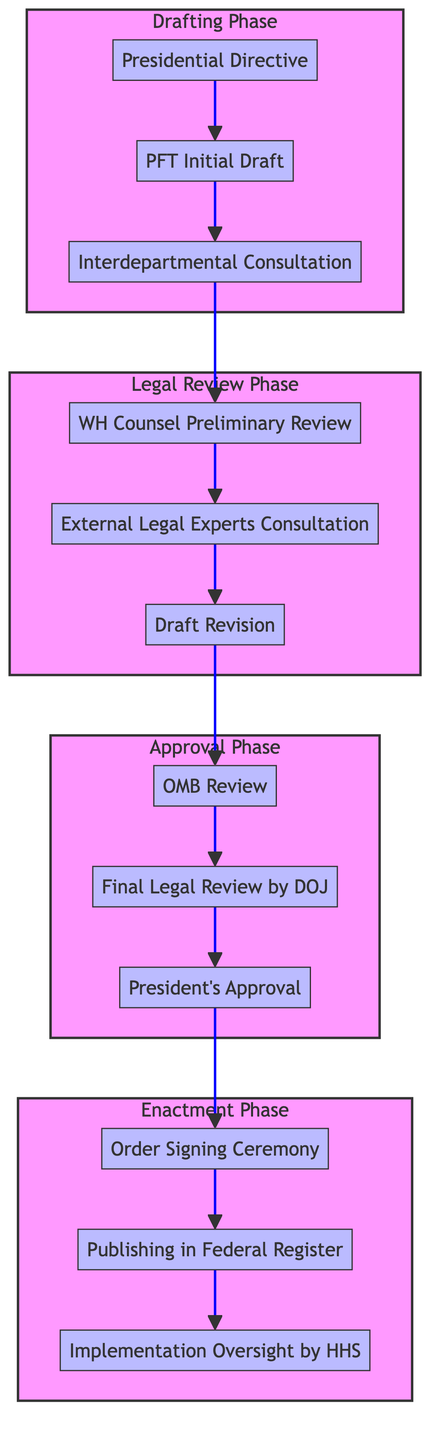What is the first step in the Drafting Phase? The first step in the Drafting Phase is represented by the first node, which is "Presidential Directive".
Answer: Presidential Directive How many steps are there in the Legal Review Phase? The Legal Review Phase has three specific steps shown in the diagram, indicating there are a total of three nodes in this phase.
Answer: 3 What follows the "Interdepartmental Consultation" in the Drafting Phase? The flow in the Drafting Phase shows "Interdepartmental Consultation" leading directly to the first step in the Legal Review Phase, which is "WH Counsel Preliminary Review".
Answer: WH Counsel Preliminary Review Which office performs the final legal review before presidential approval? The diagram indicates that the office responsible for the final legal review before obtaining the President's approval is the "DOJ".
Answer: DOJ What is the last step in the Enactment Phase? The final step listed in the Enactment Phase is "Implementation Oversight by HHS", which is the last node in that section of the diagram.
Answer: Implementation Oversight by HHS How many phases are depicted in the diagram? There are four distinct phases illustrated in the diagram, which are Drafting Phase, Legal Review Phase, Approval Phase, and Enactment Phase.
Answer: 4 What step comes after "Final Legal Review by DOJ"? Following "Final Legal Review by DOJ", the next step in the flow is "President's Approval".
Answer: President's Approval In which phase does the "External Legal Experts Consultation" occur? The "External Legal Experts Consultation" is specifically located in the Legal Review Phase, as indicated by its position in the flowchart.
Answer: Legal Review Phase What type of review is conducted by the Office of Management and Budget? In the Approval Phase, the "OMB Review" is performed, which is a legislative step before moving to the legal clearance by DOJ.
Answer: OMB Review 